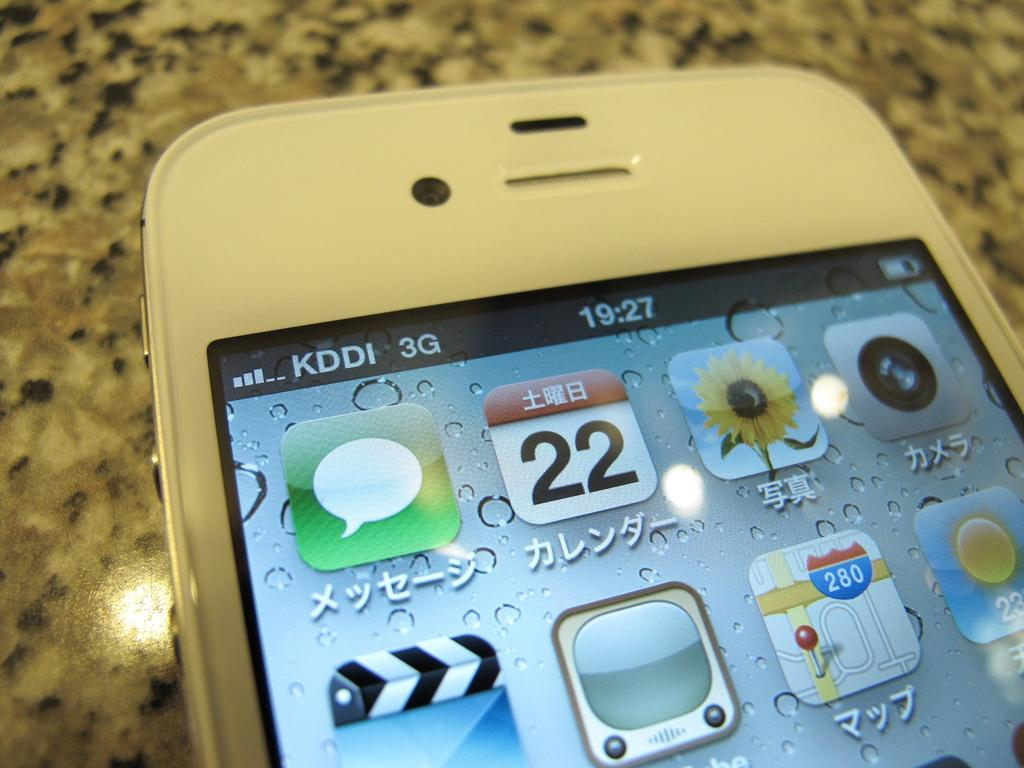Provide a one-sentence caption for the provided image. the image of a phone written in japanese on the 22 day of the month. 